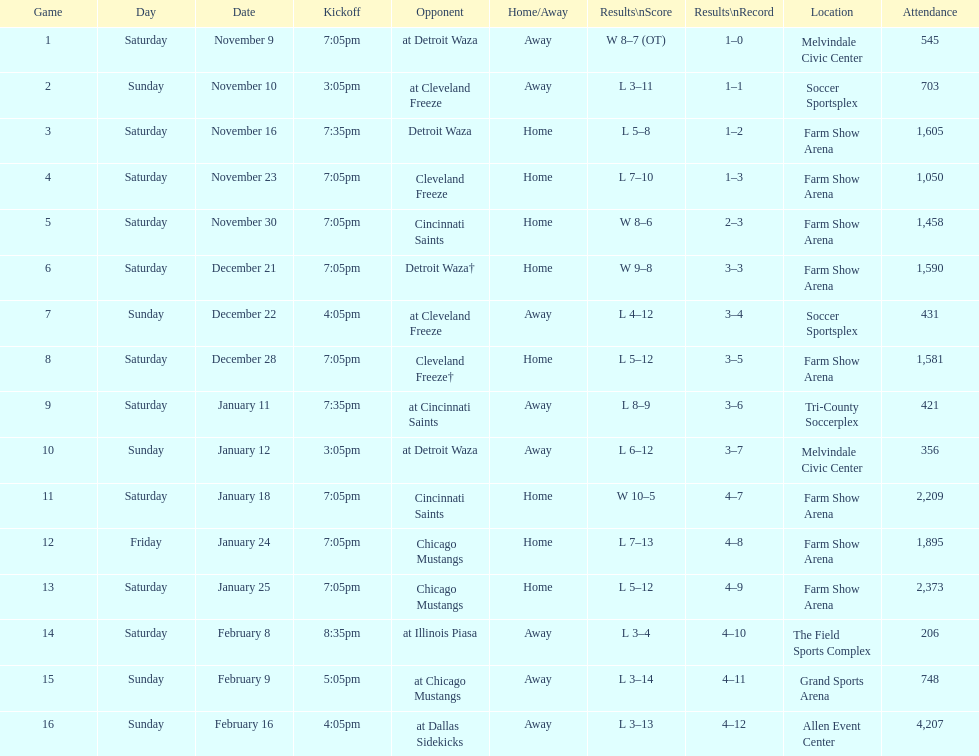Which opponent is listed first in the table? Detroit Waza. Could you parse the entire table? {'header': ['Game', 'Day', 'Date', 'Kickoff', 'Opponent', 'Home/Away', 'Results\\nScore', 'Results\\nRecord', 'Location', 'Attendance'], 'rows': [['1', 'Saturday', 'November 9', '7:05pm', 'at Detroit Waza', 'Away', 'W 8–7 (OT)', '1–0', 'Melvindale Civic Center', '545'], ['2', 'Sunday', 'November 10', '3:05pm', 'at Cleveland Freeze', 'Away', 'L 3–11', '1–1', 'Soccer Sportsplex', '703'], ['3', 'Saturday', 'November 16', '7:35pm', 'Detroit Waza', 'Home', 'L 5–8', '1–2', 'Farm Show Arena', '1,605'], ['4', 'Saturday', 'November 23', '7:05pm', 'Cleveland Freeze', 'Home', 'L 7–10', '1–3', 'Farm Show Arena', '1,050'], ['5', 'Saturday', 'November 30', '7:05pm', 'Cincinnati Saints', 'Home', 'W 8–6', '2–3', 'Farm Show Arena', '1,458'], ['6', 'Saturday', 'December 21', '7:05pm', 'Detroit Waza†', 'Home', 'W 9–8', '3–3', 'Farm Show Arena', '1,590'], ['7', 'Sunday', 'December 22', '4:05pm', 'at Cleveland Freeze', 'Away', 'L 4–12', '3–4', 'Soccer Sportsplex', '431'], ['8', 'Saturday', 'December 28', '7:05pm', 'Cleveland Freeze†', 'Home', 'L 5–12', '3–5', 'Farm Show Arena', '1,581'], ['9', 'Saturday', 'January 11', '7:35pm', 'at Cincinnati Saints', 'Away', 'L 8–9', '3–6', 'Tri-County Soccerplex', '421'], ['10', 'Sunday', 'January 12', '3:05pm', 'at Detroit Waza', 'Away', 'L 6–12', '3–7', 'Melvindale Civic Center', '356'], ['11', 'Saturday', 'January 18', '7:05pm', 'Cincinnati Saints', 'Home', 'W 10–5', '4–7', 'Farm Show Arena', '2,209'], ['12', 'Friday', 'January 24', '7:05pm', 'Chicago Mustangs', 'Home', 'L 7–13', '4–8', 'Farm Show Arena', '1,895'], ['13', 'Saturday', 'January 25', '7:05pm', 'Chicago Mustangs', 'Home', 'L 5–12', '4–9', 'Farm Show Arena', '2,373'], ['14', 'Saturday', 'February 8', '8:35pm', 'at Illinois Piasa', 'Away', 'L 3–4', '4–10', 'The Field Sports Complex', '206'], ['15', 'Sunday', 'February 9', '5:05pm', 'at Chicago Mustangs', 'Away', 'L 3–14', '4–11', 'Grand Sports Arena', '748'], ['16', 'Sunday', 'February 16', '4:05pm', 'at Dallas Sidekicks', 'Away', 'L 3–13', '4–12', 'Allen Event Center', '4,207']]} 